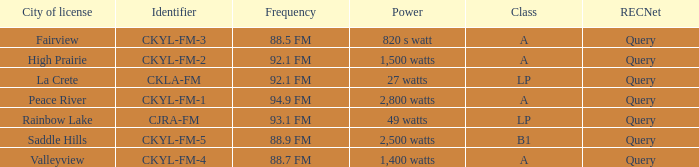What is the city of license that has a 1,400 watts power Valleyview. 